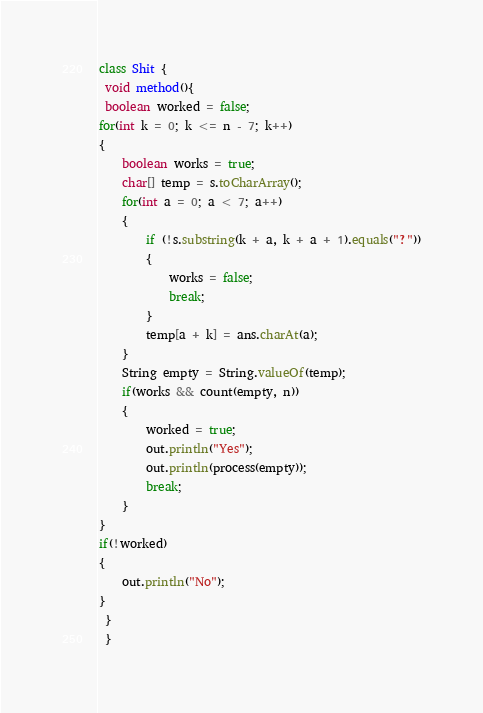Convert code to text. <code><loc_0><loc_0><loc_500><loc_500><_Java_>class Shit {
 void method(){
 boolean worked = false;
for(int k = 0; k <= n - 7; k++)
{
	boolean works = true;
	char[] temp = s.toCharArray();
	for(int a = 0; a < 7; a++)
	{
		if (!s.substring(k + a, k + a + 1).equals("?"))
		{
			works = false;
			break;
		}
		temp[a + k] = ans.charAt(a);
	}
	String empty = String.valueOf(temp);
	if(works && count(empty, n))
	{
		worked = true;
		out.println("Yes");
		out.println(process(empty));
		break;
	}
}
if(!worked)
{
	out.println("No");
}
 }
 }
</code> 